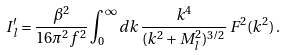<formula> <loc_0><loc_0><loc_500><loc_500>I ^ { \prime } _ { l } = \frac { \beta ^ { 2 } } { 1 6 \pi ^ { 2 } f ^ { 2 } } \int _ { 0 } ^ { \infty } d k \, \frac { k ^ { 4 } } { ( k ^ { 2 } + M _ { l } ^ { 2 } ) ^ { 3 / 2 } } \, F ^ { 2 } ( k ^ { 2 } ) \, .</formula> 